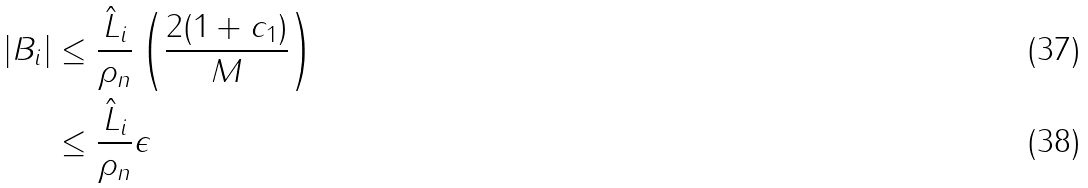<formula> <loc_0><loc_0><loc_500><loc_500>| B _ { i } | & \leq \frac { \hat { L } _ { i } } { \rho _ { n } } \left ( \frac { 2 ( 1 + c _ { 1 } ) } { M } \right ) \\ & \leq \frac { \hat { L } _ { i } } { \rho _ { n } } \epsilon</formula> 